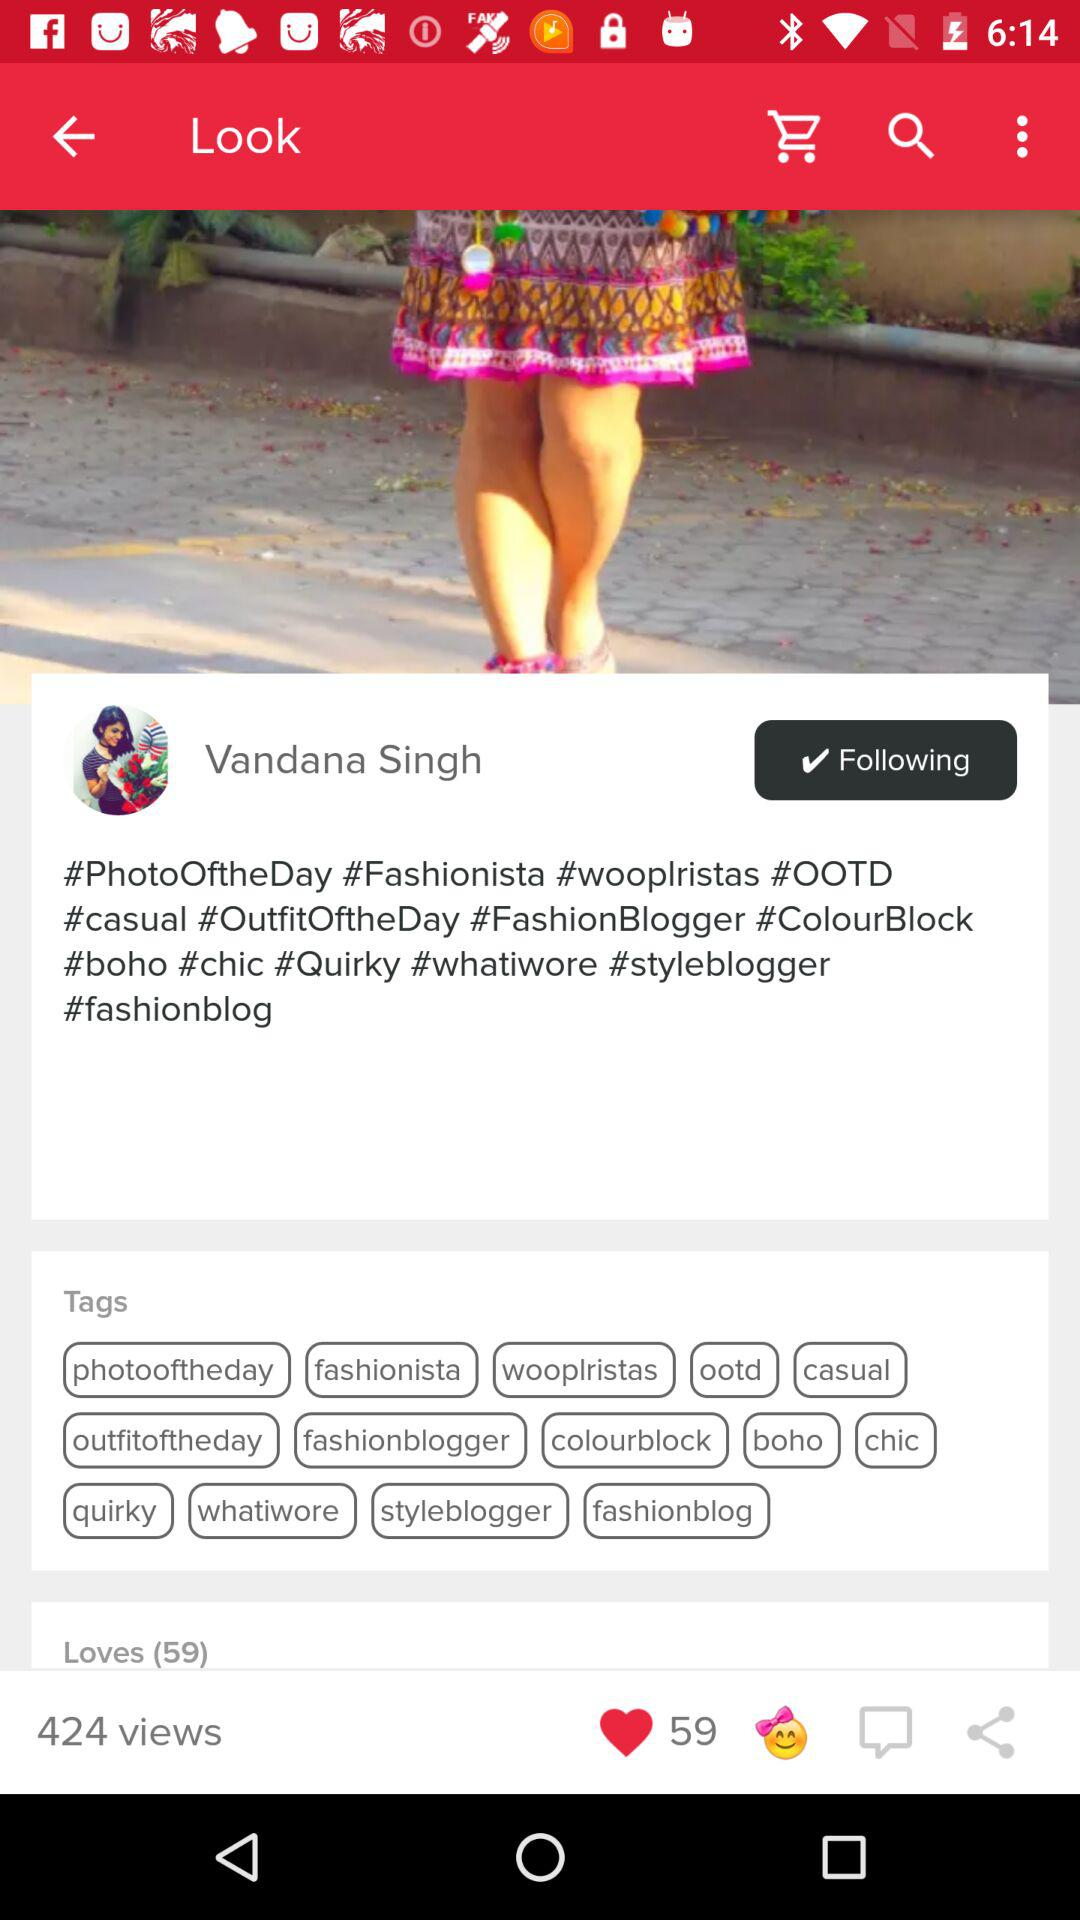What is the user name? The user name is Vandana Singh. 